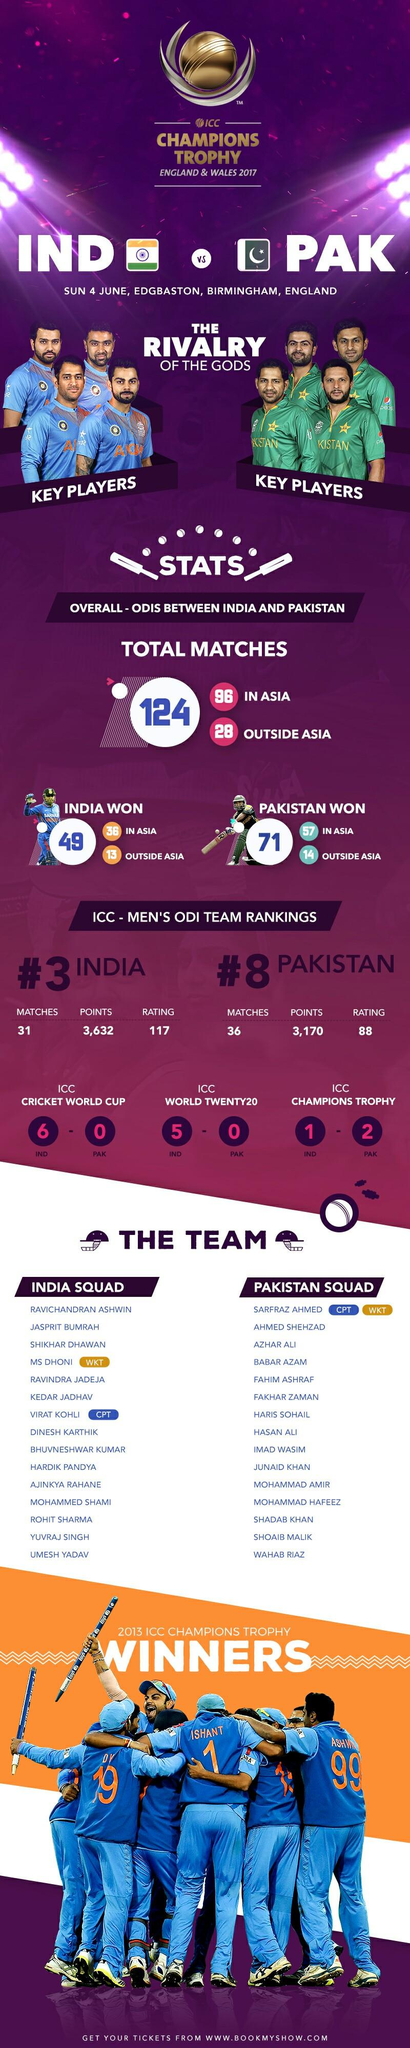Draw attention to some important aspects in this diagram. More matches were played on Asian ground than on ground outside Asia. Fahim Ashraf is the fifth member of the Pakistan team. Yuvraj Singh is the individual who occupies the second-to-last position in the lineup of Indian team members. It is Hasan Ali who is the eighth member of the Pakistan team in the list provided. 